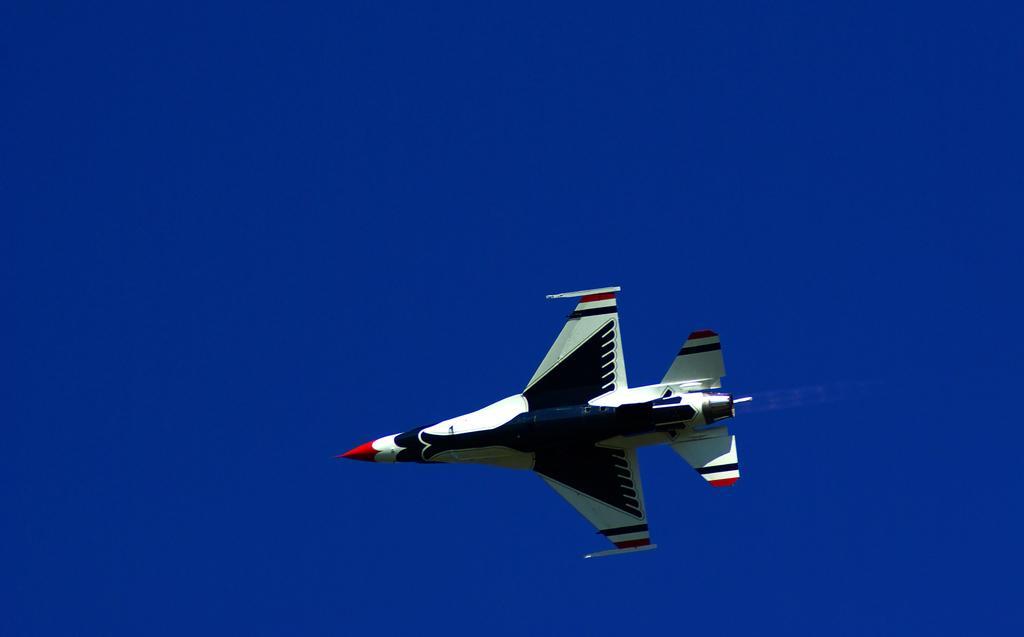Could you give a brief overview of what you see in this image? In this image I can see an aircraft flying in air and it is in white, blue and red color. Background is blue color. 